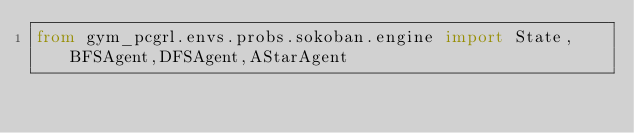Convert code to text. <code><loc_0><loc_0><loc_500><loc_500><_Python_>from gym_pcgrl.envs.probs.sokoban.engine import State,BFSAgent,DFSAgent,AStarAgent
</code> 